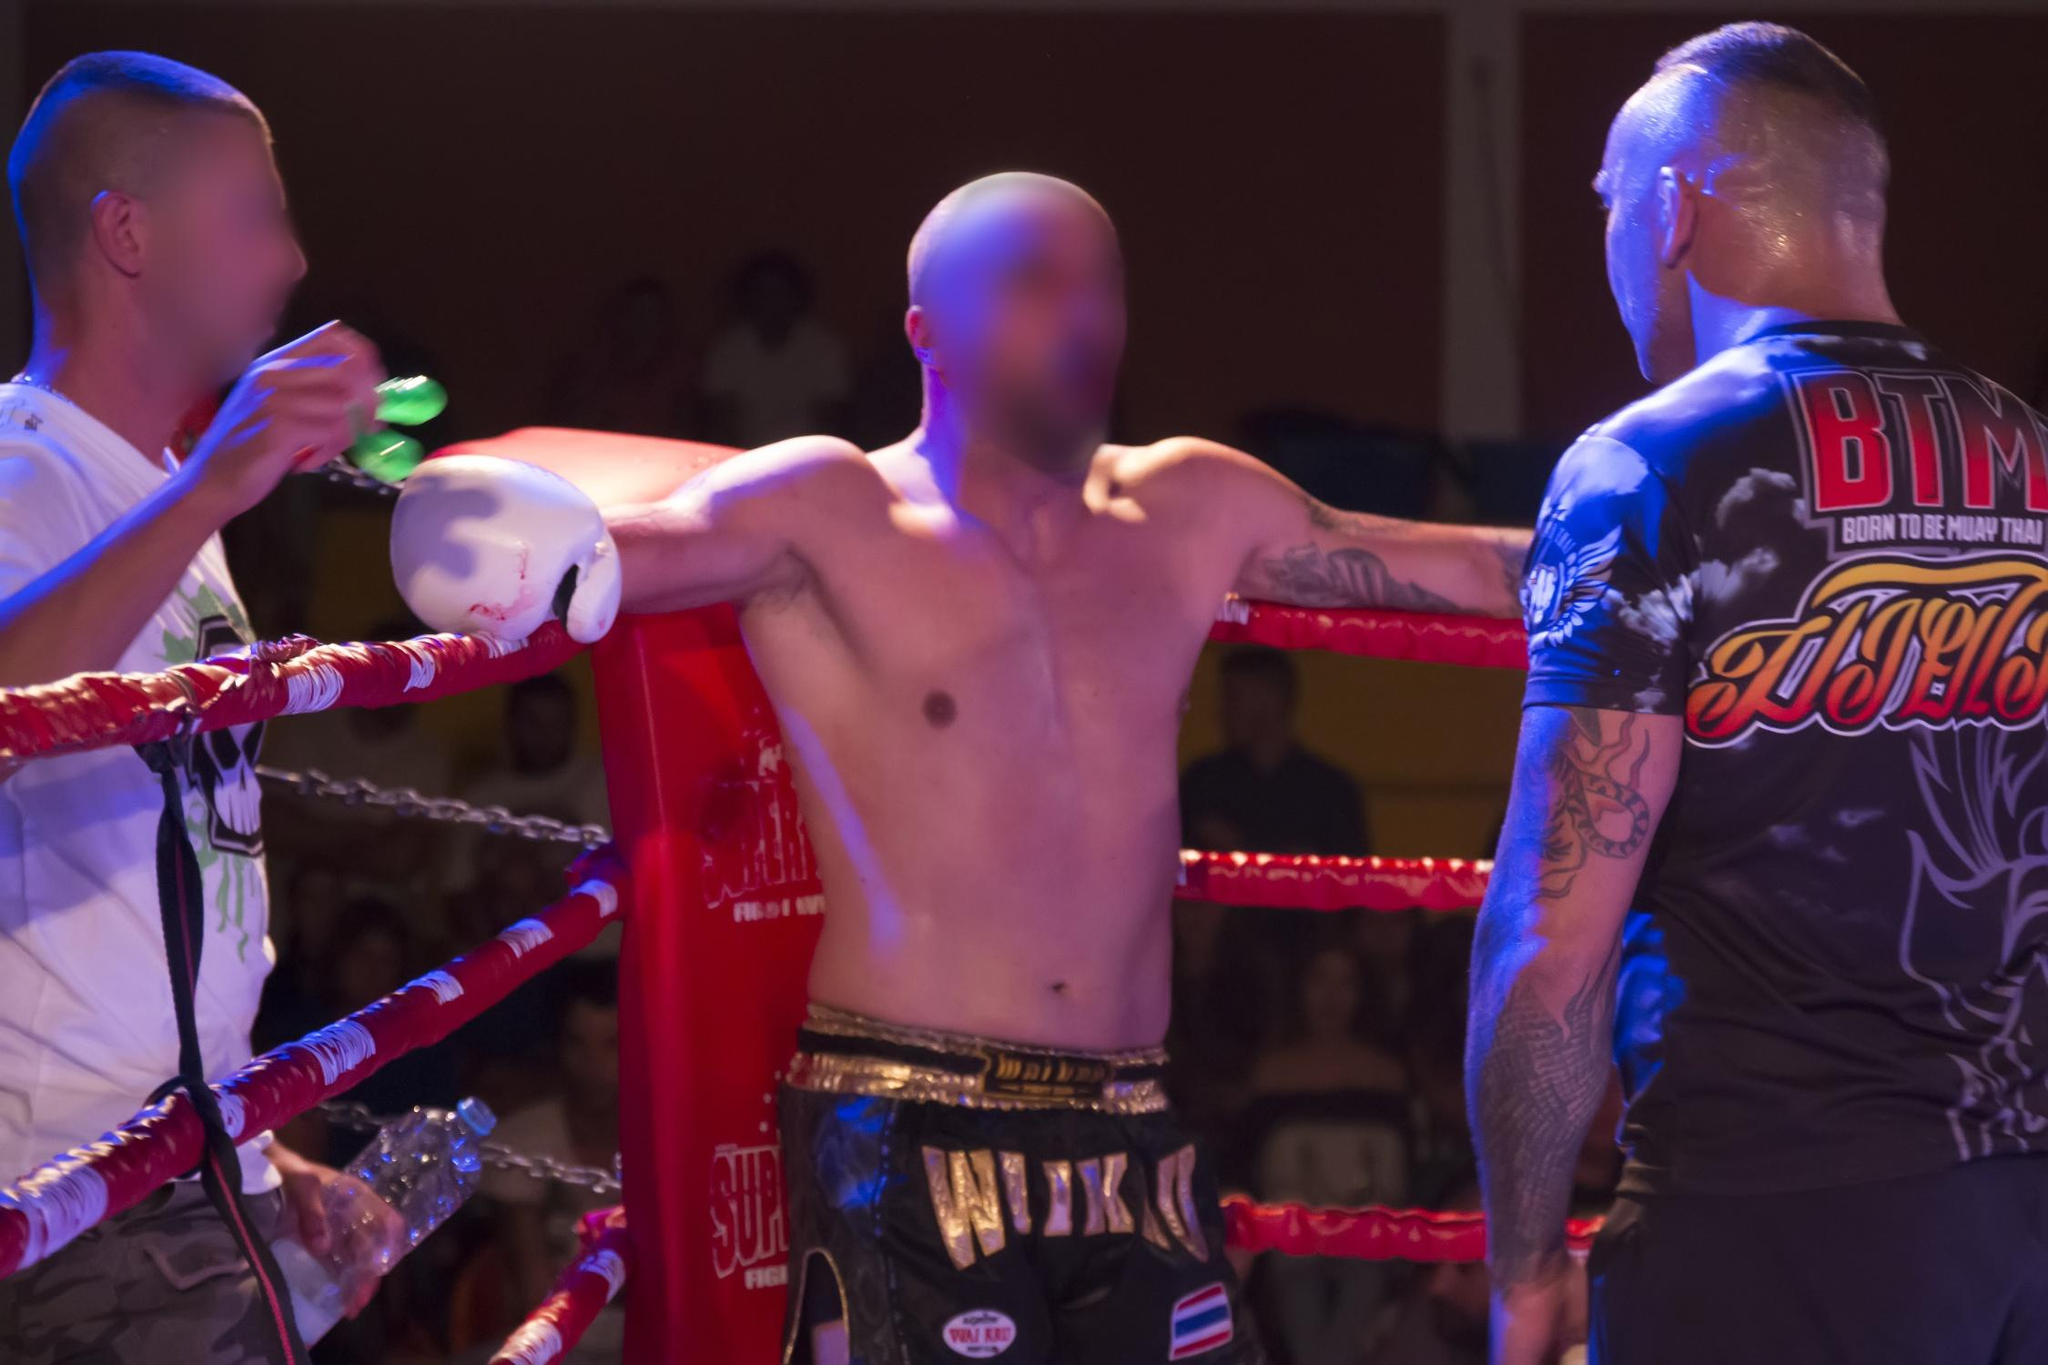Discuss the potential strategic conversation happening between the boxer and his coach. The coach, positioned close to the boxer with a water bottle in hand, suggests a moment of strategic interaction, likely offering advice or tactical adjustments. The boxer's stance, resting on the ropes and attentive to his coach, indicates receptiveness and preparation for the next round. This exchange is crucial as it could be discussing defensive techniques, offensive plans, or motivational encouragement designed to exploit the opponent's weaknesses or conserve energy for later rounds, pivotal in maintaining physical and psychological edges in the match. 